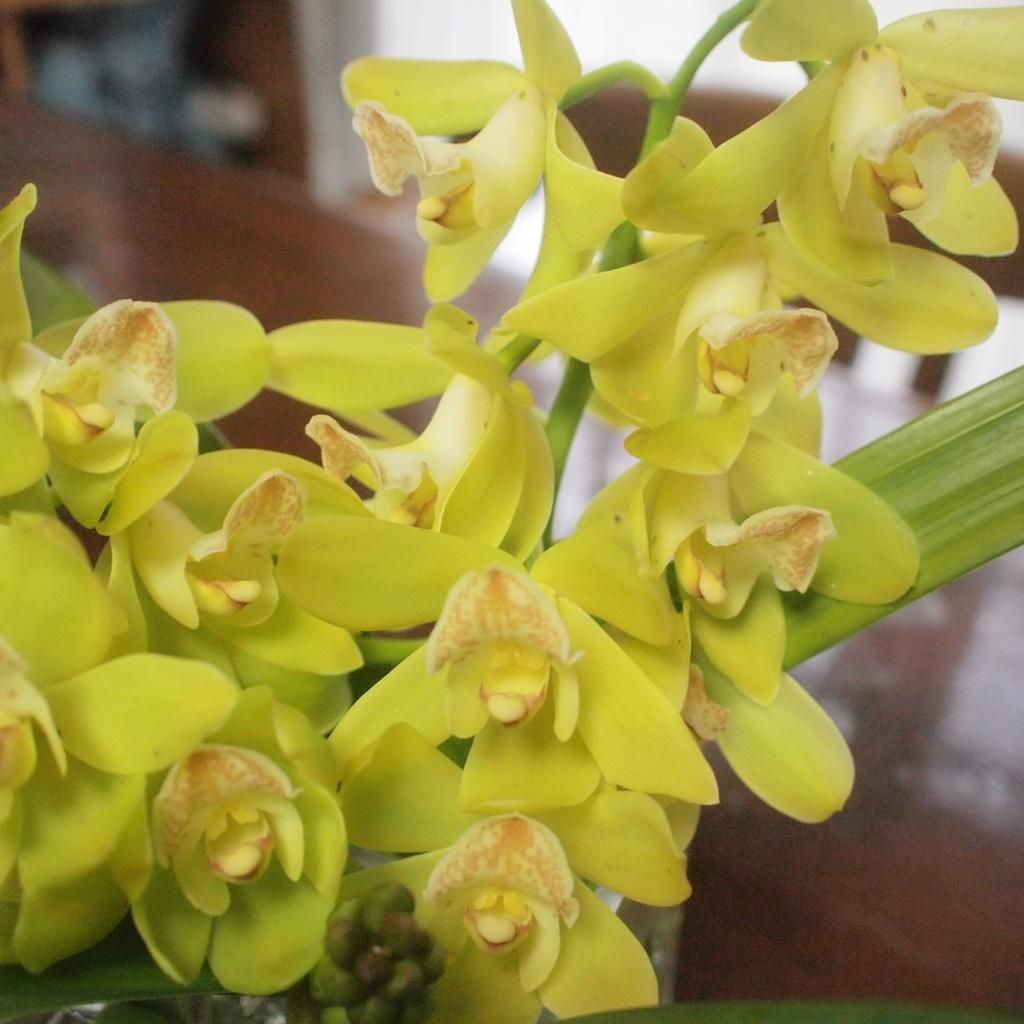What type of plant life is present in the image? There are flowers and leaves in the image. Can you describe the objects visible in the background of the image? Unfortunately, the background of the image is blurry, so it is difficult to describe the objects in detail. What is the overall focus of the image? The image appears to focus on the flowers and leaves. What type of stove is visible in the image? There is no stove present in the image. What effect does the stove have on the flowers in the image? Since there is no stove in the image, it cannot have any effect on the flowers. 